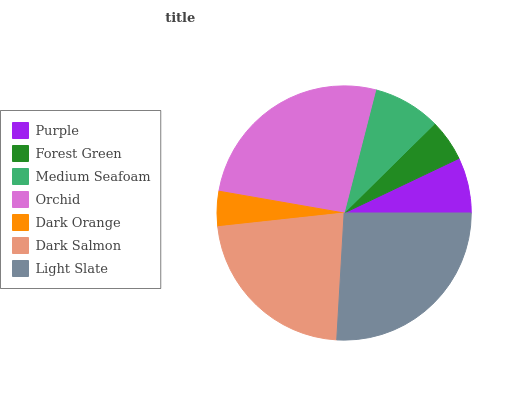Is Dark Orange the minimum?
Answer yes or no. Yes. Is Orchid the maximum?
Answer yes or no. Yes. Is Forest Green the minimum?
Answer yes or no. No. Is Forest Green the maximum?
Answer yes or no. No. Is Purple greater than Forest Green?
Answer yes or no. Yes. Is Forest Green less than Purple?
Answer yes or no. Yes. Is Forest Green greater than Purple?
Answer yes or no. No. Is Purple less than Forest Green?
Answer yes or no. No. Is Medium Seafoam the high median?
Answer yes or no. Yes. Is Medium Seafoam the low median?
Answer yes or no. Yes. Is Light Slate the high median?
Answer yes or no. No. Is Orchid the low median?
Answer yes or no. No. 